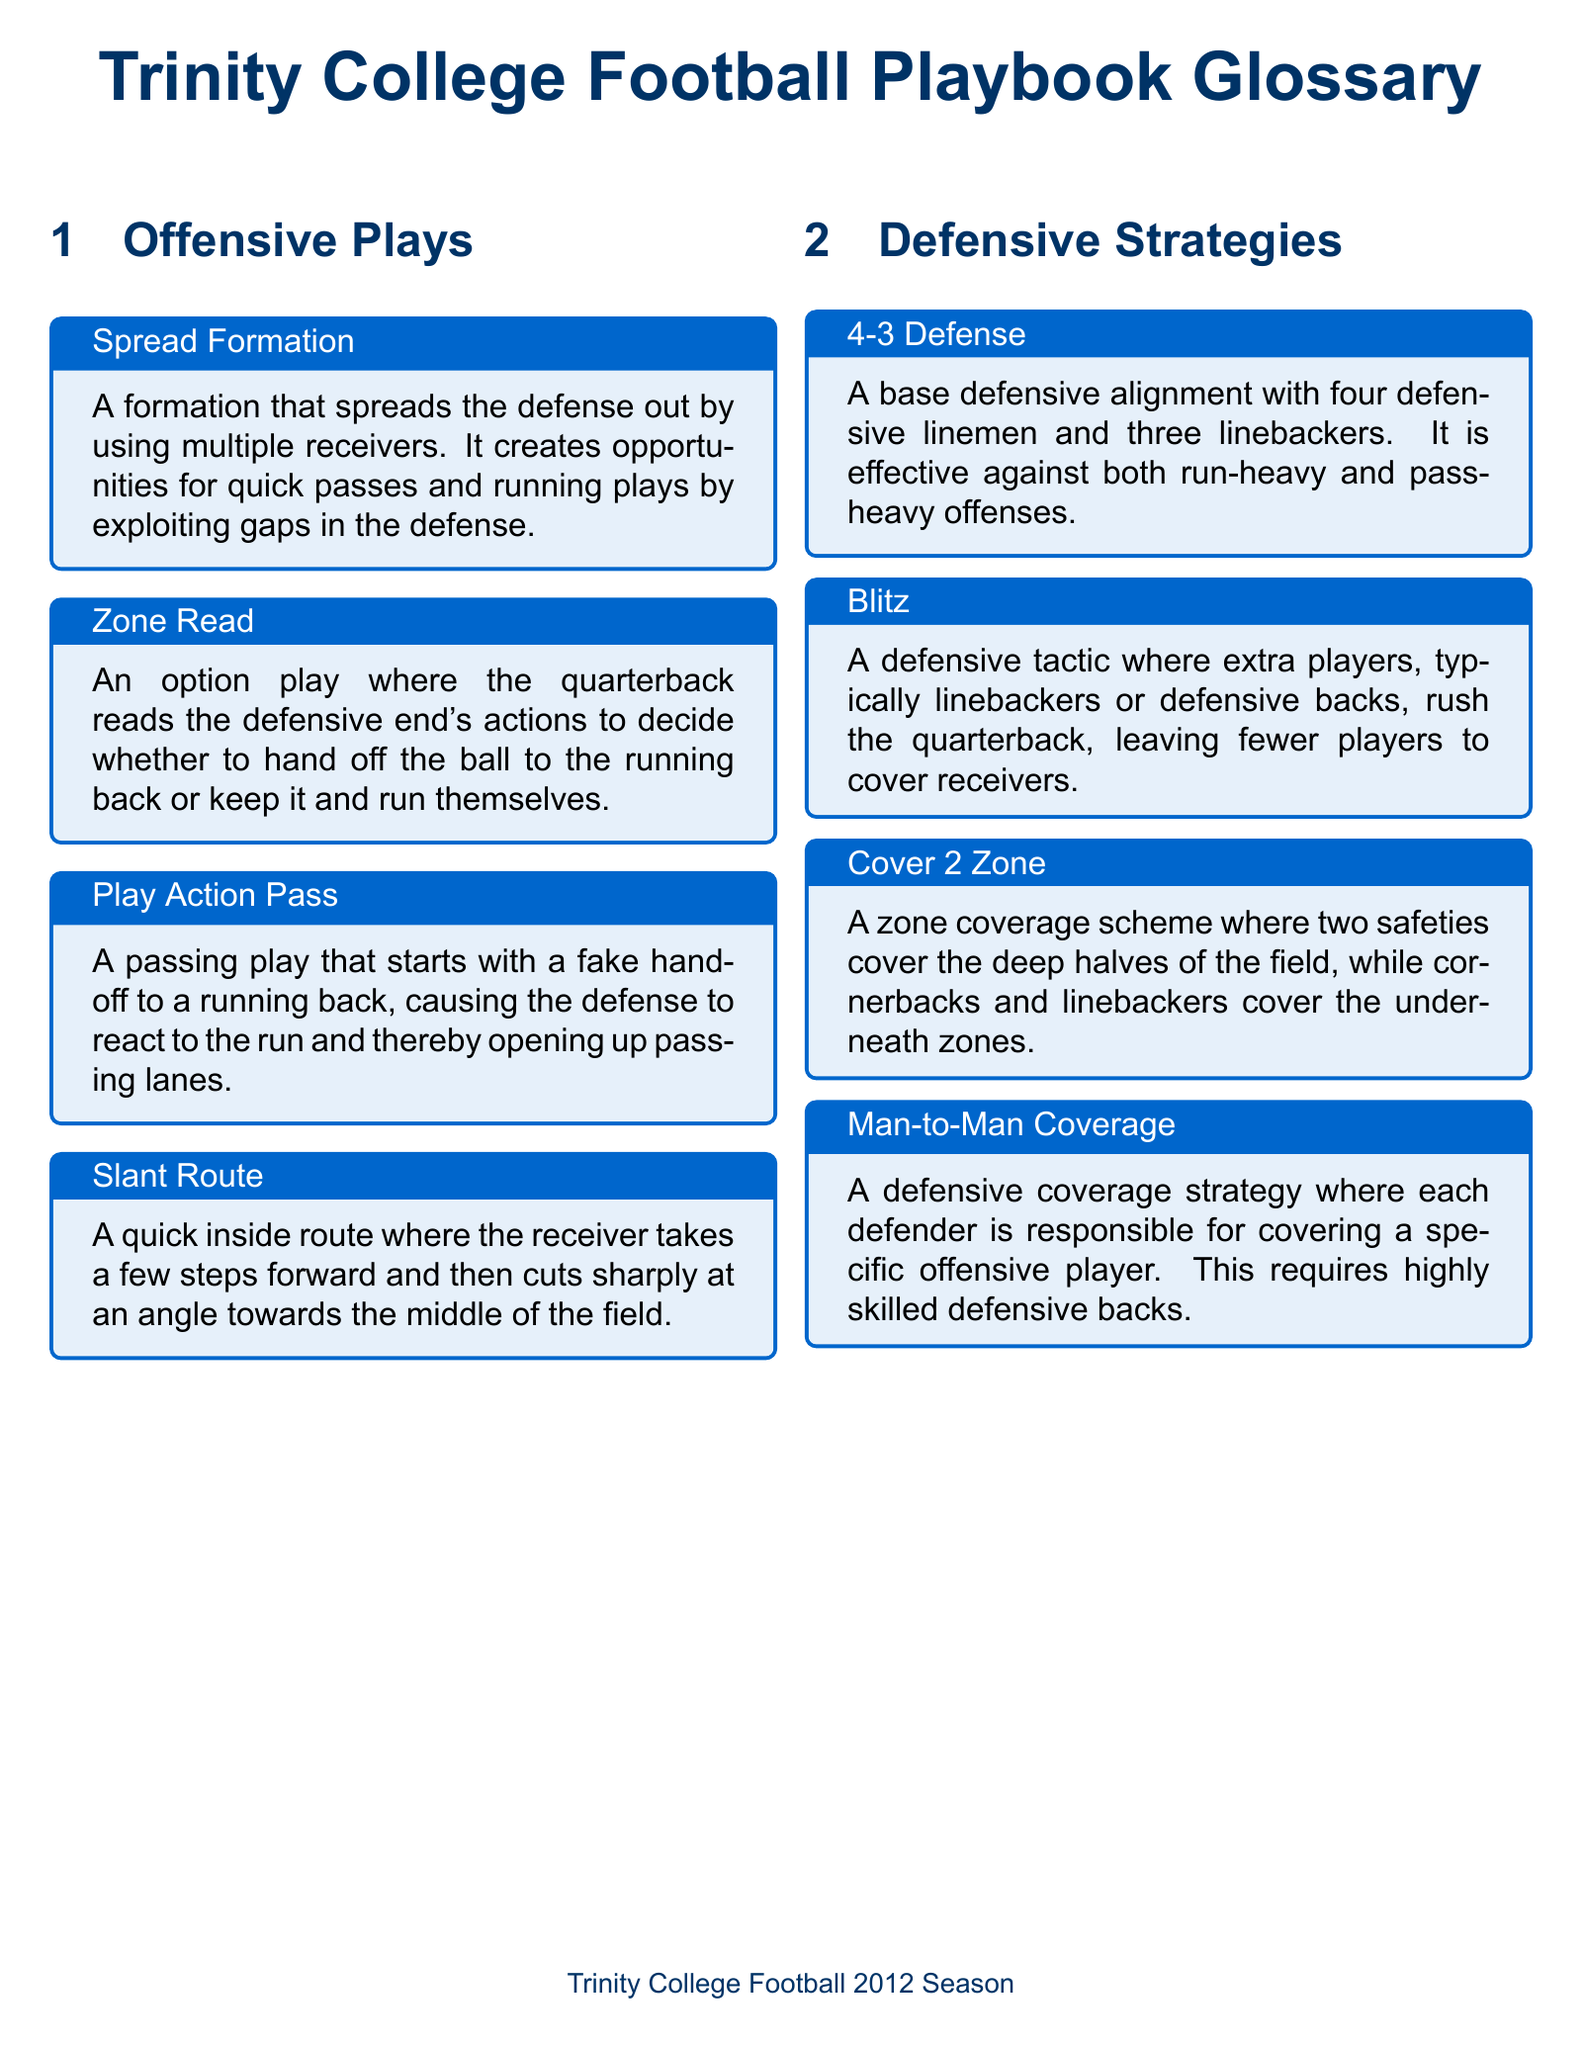What is the title of the document? The title of the document is given in a prominent header format.
Answer: Trinity College Football Playbook Glossary What formation is designed to spread the defense out? The document provides a specific term associated with this strategy in offensive plays.
Answer: Spread Formation What is the main characteristic of the 4-3 Defense? The document describes a specific alignment in defensive strategies, emphasizing the number of players in each category.
Answer: Four defensive linemen and three linebackers Which offensive play starts with a fake handoff? The glossary outlines a particular passing play that initiates with a deceptive move.
Answer: Play Action Pass What defensive tactic involves rushing the quarterback with extra players? This term describes a specific aggressive strategy within the defensive section of the document.
Answer: Blitz What coverage scheme has two safeties covering the deep halves? This question refers to a specific coverage style explained in the defensive strategies section.
Answer: Cover 2 Zone What type of route does a receiver take in a slant route? The definition includes details about the receiver's movement in this offensive strategy.
Answer: Cuts sharply at an angle toward the middle How many linebackers are typically in a 4-3 Defense? This question seeks numerical information from the defensive strategies section.
Answer: Three linebackers What does the Zone Read involve? The glossary explains a specific option play that relies on the quarterback's decision-making in response to defenders.
Answer: Reading the defensive end's actions 